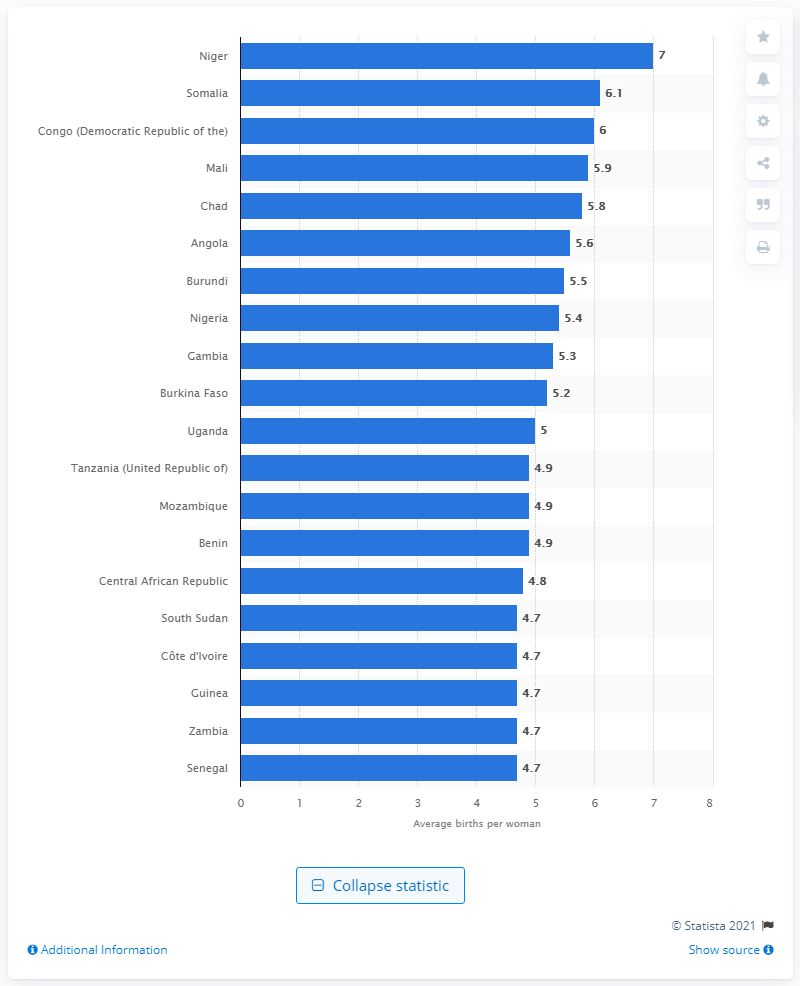How does birth rate correlate with economic development? Generally, there is an inverse relationship between birth rates and economic development. As countries develop economically, they often experience a decline in average birth rates due to factors such as improved access to education and healthcare, increased employment opportunities, particularly for women, and a greater prevalence of family planning. 